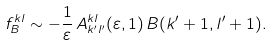<formula> <loc_0><loc_0><loc_500><loc_500>f _ { B } ^ { k l } \sim - \frac { 1 } { \varepsilon } \, A ^ { k l } _ { k ^ { \prime } l ^ { \prime } } ( \varepsilon , 1 ) \, B ( k ^ { \prime } + 1 , l ^ { \prime } + 1 ) .</formula> 